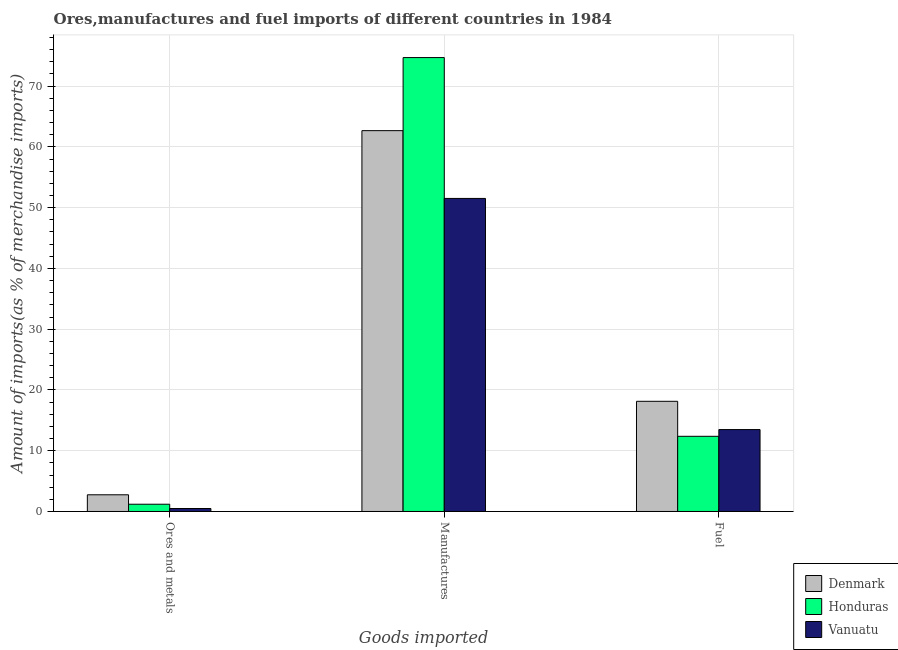How many groups of bars are there?
Offer a very short reply. 3. Are the number of bars per tick equal to the number of legend labels?
Ensure brevity in your answer.  Yes. How many bars are there on the 3rd tick from the right?
Your answer should be compact. 3. What is the label of the 1st group of bars from the left?
Offer a terse response. Ores and metals. What is the percentage of ores and metals imports in Vanuatu?
Offer a terse response. 0.49. Across all countries, what is the maximum percentage of fuel imports?
Give a very brief answer. 18.13. Across all countries, what is the minimum percentage of fuel imports?
Your answer should be very brief. 12.37. In which country was the percentage of manufactures imports minimum?
Offer a terse response. Vanuatu. What is the total percentage of ores and metals imports in the graph?
Provide a short and direct response. 4.43. What is the difference between the percentage of ores and metals imports in Honduras and that in Denmark?
Make the answer very short. -1.55. What is the difference between the percentage of ores and metals imports in Honduras and the percentage of manufactures imports in Denmark?
Ensure brevity in your answer.  -61.48. What is the average percentage of manufactures imports per country?
Offer a terse response. 62.97. What is the difference between the percentage of ores and metals imports and percentage of fuel imports in Denmark?
Give a very brief answer. -15.39. In how many countries, is the percentage of fuel imports greater than 36 %?
Provide a succinct answer. 0. What is the ratio of the percentage of ores and metals imports in Vanuatu to that in Honduras?
Your response must be concise. 0.41. Is the percentage of fuel imports in Denmark less than that in Vanuatu?
Make the answer very short. No. What is the difference between the highest and the second highest percentage of fuel imports?
Your response must be concise. 4.65. What is the difference between the highest and the lowest percentage of ores and metals imports?
Your answer should be very brief. 2.26. In how many countries, is the percentage of fuel imports greater than the average percentage of fuel imports taken over all countries?
Your response must be concise. 1. Is the sum of the percentage of manufactures imports in Vanuatu and Honduras greater than the maximum percentage of fuel imports across all countries?
Ensure brevity in your answer.  Yes. What does the 2nd bar from the left in Ores and metals represents?
Your answer should be compact. Honduras. What does the 1st bar from the right in Ores and metals represents?
Keep it short and to the point. Vanuatu. Is it the case that in every country, the sum of the percentage of ores and metals imports and percentage of manufactures imports is greater than the percentage of fuel imports?
Your response must be concise. Yes. Are all the bars in the graph horizontal?
Make the answer very short. No. How many countries are there in the graph?
Offer a very short reply. 3. Are the values on the major ticks of Y-axis written in scientific E-notation?
Your response must be concise. No. Does the graph contain any zero values?
Your response must be concise. No. How are the legend labels stacked?
Your response must be concise. Vertical. What is the title of the graph?
Keep it short and to the point. Ores,manufactures and fuel imports of different countries in 1984. Does "Guam" appear as one of the legend labels in the graph?
Your response must be concise. No. What is the label or title of the X-axis?
Make the answer very short. Goods imported. What is the label or title of the Y-axis?
Provide a short and direct response. Amount of imports(as % of merchandise imports). What is the Amount of imports(as % of merchandise imports) of Denmark in Ores and metals?
Your answer should be compact. 2.75. What is the Amount of imports(as % of merchandise imports) in Honduras in Ores and metals?
Your answer should be compact. 1.19. What is the Amount of imports(as % of merchandise imports) in Vanuatu in Ores and metals?
Your answer should be compact. 0.49. What is the Amount of imports(as % of merchandise imports) of Denmark in Manufactures?
Offer a very short reply. 62.68. What is the Amount of imports(as % of merchandise imports) in Honduras in Manufactures?
Make the answer very short. 74.7. What is the Amount of imports(as % of merchandise imports) of Vanuatu in Manufactures?
Offer a very short reply. 51.52. What is the Amount of imports(as % of merchandise imports) in Denmark in Fuel?
Offer a terse response. 18.13. What is the Amount of imports(as % of merchandise imports) in Honduras in Fuel?
Your answer should be compact. 12.37. What is the Amount of imports(as % of merchandise imports) of Vanuatu in Fuel?
Offer a terse response. 13.48. Across all Goods imported, what is the maximum Amount of imports(as % of merchandise imports) of Denmark?
Your answer should be compact. 62.68. Across all Goods imported, what is the maximum Amount of imports(as % of merchandise imports) of Honduras?
Your response must be concise. 74.7. Across all Goods imported, what is the maximum Amount of imports(as % of merchandise imports) of Vanuatu?
Ensure brevity in your answer.  51.52. Across all Goods imported, what is the minimum Amount of imports(as % of merchandise imports) in Denmark?
Provide a succinct answer. 2.75. Across all Goods imported, what is the minimum Amount of imports(as % of merchandise imports) of Honduras?
Ensure brevity in your answer.  1.19. Across all Goods imported, what is the minimum Amount of imports(as % of merchandise imports) in Vanuatu?
Your response must be concise. 0.49. What is the total Amount of imports(as % of merchandise imports) of Denmark in the graph?
Give a very brief answer. 83.56. What is the total Amount of imports(as % of merchandise imports) of Honduras in the graph?
Provide a short and direct response. 88.27. What is the total Amount of imports(as % of merchandise imports) in Vanuatu in the graph?
Your response must be concise. 65.49. What is the difference between the Amount of imports(as % of merchandise imports) in Denmark in Ores and metals and that in Manufactures?
Ensure brevity in your answer.  -59.93. What is the difference between the Amount of imports(as % of merchandise imports) in Honduras in Ores and metals and that in Manufactures?
Give a very brief answer. -73.51. What is the difference between the Amount of imports(as % of merchandise imports) in Vanuatu in Ores and metals and that in Manufactures?
Your response must be concise. -51.03. What is the difference between the Amount of imports(as % of merchandise imports) in Denmark in Ores and metals and that in Fuel?
Offer a terse response. -15.39. What is the difference between the Amount of imports(as % of merchandise imports) in Honduras in Ores and metals and that in Fuel?
Ensure brevity in your answer.  -11.18. What is the difference between the Amount of imports(as % of merchandise imports) of Vanuatu in Ores and metals and that in Fuel?
Offer a very short reply. -12.99. What is the difference between the Amount of imports(as % of merchandise imports) in Denmark in Manufactures and that in Fuel?
Keep it short and to the point. 44.54. What is the difference between the Amount of imports(as % of merchandise imports) in Honduras in Manufactures and that in Fuel?
Ensure brevity in your answer.  62.33. What is the difference between the Amount of imports(as % of merchandise imports) of Vanuatu in Manufactures and that in Fuel?
Offer a terse response. 38.04. What is the difference between the Amount of imports(as % of merchandise imports) in Denmark in Ores and metals and the Amount of imports(as % of merchandise imports) in Honduras in Manufactures?
Make the answer very short. -71.96. What is the difference between the Amount of imports(as % of merchandise imports) of Denmark in Ores and metals and the Amount of imports(as % of merchandise imports) of Vanuatu in Manufactures?
Keep it short and to the point. -48.78. What is the difference between the Amount of imports(as % of merchandise imports) in Honduras in Ores and metals and the Amount of imports(as % of merchandise imports) in Vanuatu in Manufactures?
Ensure brevity in your answer.  -50.33. What is the difference between the Amount of imports(as % of merchandise imports) of Denmark in Ores and metals and the Amount of imports(as % of merchandise imports) of Honduras in Fuel?
Give a very brief answer. -9.63. What is the difference between the Amount of imports(as % of merchandise imports) of Denmark in Ores and metals and the Amount of imports(as % of merchandise imports) of Vanuatu in Fuel?
Make the answer very short. -10.73. What is the difference between the Amount of imports(as % of merchandise imports) in Honduras in Ores and metals and the Amount of imports(as % of merchandise imports) in Vanuatu in Fuel?
Provide a short and direct response. -12.29. What is the difference between the Amount of imports(as % of merchandise imports) of Denmark in Manufactures and the Amount of imports(as % of merchandise imports) of Honduras in Fuel?
Your answer should be very brief. 50.31. What is the difference between the Amount of imports(as % of merchandise imports) of Denmark in Manufactures and the Amount of imports(as % of merchandise imports) of Vanuatu in Fuel?
Offer a very short reply. 49.2. What is the difference between the Amount of imports(as % of merchandise imports) of Honduras in Manufactures and the Amount of imports(as % of merchandise imports) of Vanuatu in Fuel?
Keep it short and to the point. 61.22. What is the average Amount of imports(as % of merchandise imports) in Denmark per Goods imported?
Your answer should be compact. 27.85. What is the average Amount of imports(as % of merchandise imports) of Honduras per Goods imported?
Provide a short and direct response. 29.42. What is the average Amount of imports(as % of merchandise imports) in Vanuatu per Goods imported?
Your response must be concise. 21.83. What is the difference between the Amount of imports(as % of merchandise imports) in Denmark and Amount of imports(as % of merchandise imports) in Honduras in Ores and metals?
Provide a succinct answer. 1.55. What is the difference between the Amount of imports(as % of merchandise imports) in Denmark and Amount of imports(as % of merchandise imports) in Vanuatu in Ores and metals?
Provide a short and direct response. 2.26. What is the difference between the Amount of imports(as % of merchandise imports) of Honduras and Amount of imports(as % of merchandise imports) of Vanuatu in Ores and metals?
Your response must be concise. 0.7. What is the difference between the Amount of imports(as % of merchandise imports) of Denmark and Amount of imports(as % of merchandise imports) of Honduras in Manufactures?
Your answer should be compact. -12.03. What is the difference between the Amount of imports(as % of merchandise imports) of Denmark and Amount of imports(as % of merchandise imports) of Vanuatu in Manufactures?
Make the answer very short. 11.16. What is the difference between the Amount of imports(as % of merchandise imports) in Honduras and Amount of imports(as % of merchandise imports) in Vanuatu in Manufactures?
Offer a terse response. 23.18. What is the difference between the Amount of imports(as % of merchandise imports) of Denmark and Amount of imports(as % of merchandise imports) of Honduras in Fuel?
Your answer should be compact. 5.76. What is the difference between the Amount of imports(as % of merchandise imports) of Denmark and Amount of imports(as % of merchandise imports) of Vanuatu in Fuel?
Provide a short and direct response. 4.65. What is the difference between the Amount of imports(as % of merchandise imports) of Honduras and Amount of imports(as % of merchandise imports) of Vanuatu in Fuel?
Provide a short and direct response. -1.11. What is the ratio of the Amount of imports(as % of merchandise imports) in Denmark in Ores and metals to that in Manufactures?
Your answer should be compact. 0.04. What is the ratio of the Amount of imports(as % of merchandise imports) in Honduras in Ores and metals to that in Manufactures?
Your response must be concise. 0.02. What is the ratio of the Amount of imports(as % of merchandise imports) in Vanuatu in Ores and metals to that in Manufactures?
Offer a terse response. 0.01. What is the ratio of the Amount of imports(as % of merchandise imports) in Denmark in Ores and metals to that in Fuel?
Ensure brevity in your answer.  0.15. What is the ratio of the Amount of imports(as % of merchandise imports) of Honduras in Ores and metals to that in Fuel?
Offer a terse response. 0.1. What is the ratio of the Amount of imports(as % of merchandise imports) in Vanuatu in Ores and metals to that in Fuel?
Offer a very short reply. 0.04. What is the ratio of the Amount of imports(as % of merchandise imports) of Denmark in Manufactures to that in Fuel?
Provide a short and direct response. 3.46. What is the ratio of the Amount of imports(as % of merchandise imports) in Honduras in Manufactures to that in Fuel?
Provide a succinct answer. 6.04. What is the ratio of the Amount of imports(as % of merchandise imports) in Vanuatu in Manufactures to that in Fuel?
Keep it short and to the point. 3.82. What is the difference between the highest and the second highest Amount of imports(as % of merchandise imports) of Denmark?
Provide a succinct answer. 44.54. What is the difference between the highest and the second highest Amount of imports(as % of merchandise imports) of Honduras?
Your answer should be very brief. 62.33. What is the difference between the highest and the second highest Amount of imports(as % of merchandise imports) in Vanuatu?
Make the answer very short. 38.04. What is the difference between the highest and the lowest Amount of imports(as % of merchandise imports) in Denmark?
Ensure brevity in your answer.  59.93. What is the difference between the highest and the lowest Amount of imports(as % of merchandise imports) of Honduras?
Make the answer very short. 73.51. What is the difference between the highest and the lowest Amount of imports(as % of merchandise imports) of Vanuatu?
Provide a short and direct response. 51.03. 